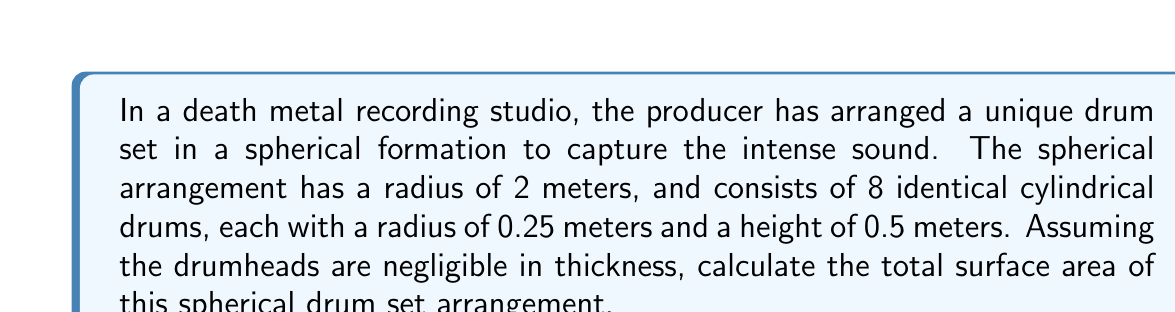What is the answer to this math problem? To solve this problem, we need to calculate the surface area of the sphere and subtract the area of the circular openings where the drums are placed, then add the surface area of all the drums.

1. Surface area of the sphere:
   $$A_{sphere} = 4\pi r^2 = 4\pi (2)^2 = 16\pi \text{ m}^2$$

2. Area of one circular opening:
   $$A_{opening} = \pi r^2 = \pi (0.25)^2 = 0.0625\pi \text{ m}^2$$

3. Total area of 8 openings:
   $$A_{total\_openings} = 8 \times 0.0625\pi = 0.5\pi \text{ m}^2$$

4. Surface area of one drum (excluding top and bottom):
   $$A_{drum\_side} = 2\pi rh = 2\pi (0.25)(0.5) = 0.25\pi \text{ m}^2$$

5. Surface area of top and bottom of one drum:
   $$A_{drum\_ends} = 2\pi r^2 = 2\pi (0.25)^2 = 0.125\pi \text{ m}^2$$

6. Total surface area of one drum:
   $$A_{drum} = A_{drum\_side} + A_{drum\_ends} = 0.25\pi + 0.125\pi = 0.375\pi \text{ m}^2$$

7. Total surface area of 8 drums:
   $$A_{total\_drums} = 8 \times 0.375\pi = 3\pi \text{ m}^2$$

8. Final surface area:
   $$A_{final} = A_{sphere} - A_{total\_openings} + A_{total\_drums}$$
   $$A_{final} = 16\pi - 0.5\pi + 3\pi = 18.5\pi \text{ m}^2$$
Answer: The total surface area of the spherical drum set arrangement is $18.5\pi \text{ m}^2$ or approximately 58.12 m². 